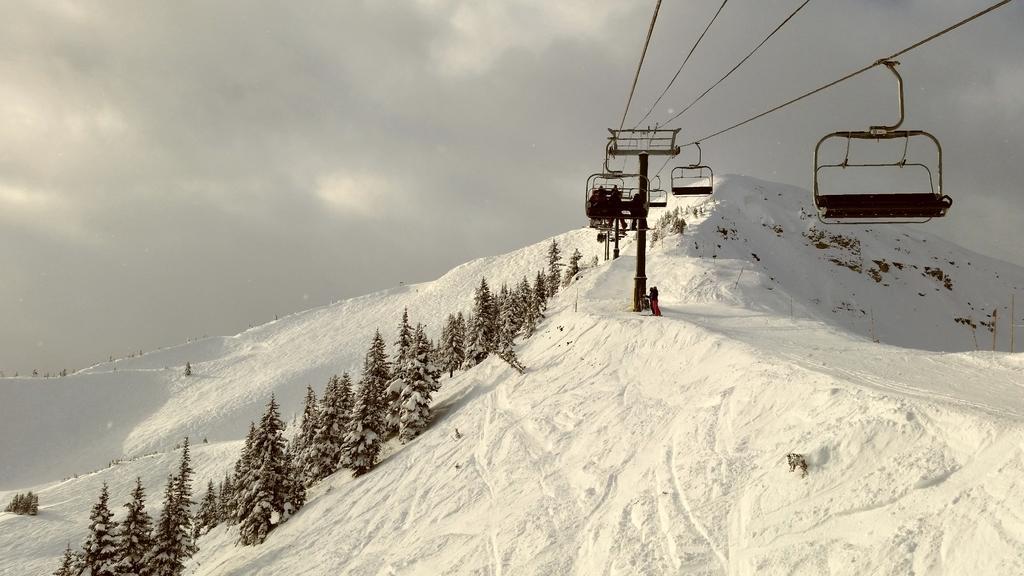Describe this image in one or two sentences. As we can see in the image there are trees, cable cars and few people. There is snow and at the top there is sky. 